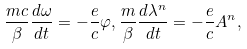Convert formula to latex. <formula><loc_0><loc_0><loc_500><loc_500>\frac { m c } { \beta } \frac { d \omega } { d t } = - \frac { e } { c } \varphi , \frac { m } { \beta } \frac { d \lambda ^ { n } } { d t } = - \frac { e } { c } A ^ { n } ,</formula> 